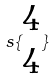<formula> <loc_0><loc_0><loc_500><loc_500>s \{ \begin{matrix} 4 \\ 4 \end{matrix} \}</formula> 